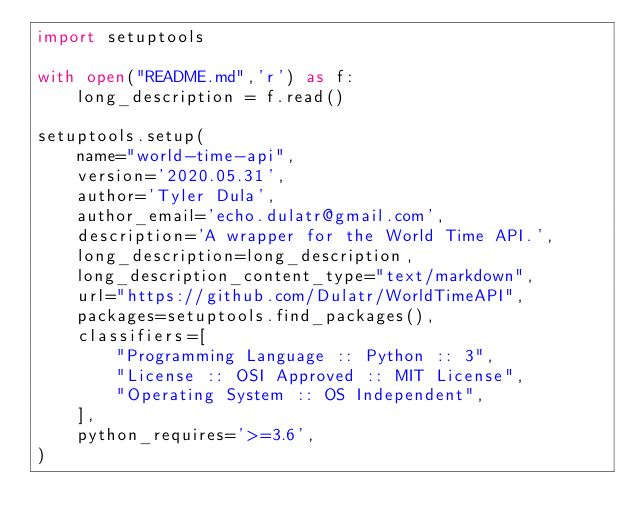<code> <loc_0><loc_0><loc_500><loc_500><_Python_>import setuptools

with open("README.md",'r') as f:
    long_description = f.read()

setuptools.setup(
    name="world-time-api",
    version='2020.05.31',
    author='Tyler Dula',
    author_email='echo.dulatr@gmail.com',
    description='A wrapper for the World Time API.',
    long_description=long_description,
    long_description_content_type="text/markdown",
    url="https://github.com/Dulatr/WorldTimeAPI",
    packages=setuptools.find_packages(),
    classifiers=[
        "Programming Language :: Python :: 3",
        "License :: OSI Approved :: MIT License",
        "Operating System :: OS Independent",
    ],
    python_requires='>=3.6',
)</code> 